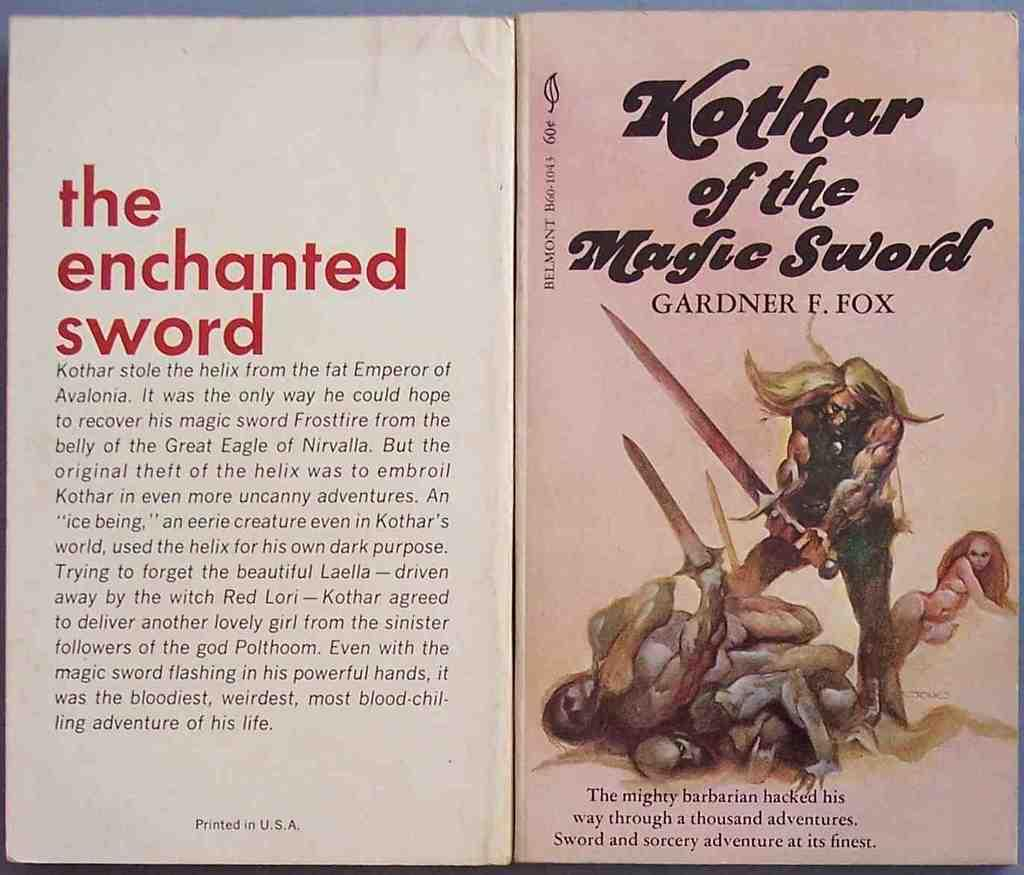<image>
Share a concise interpretation of the image provided. Cover for Kothar of the Magic Sword showing a man wielding a giant sword. 